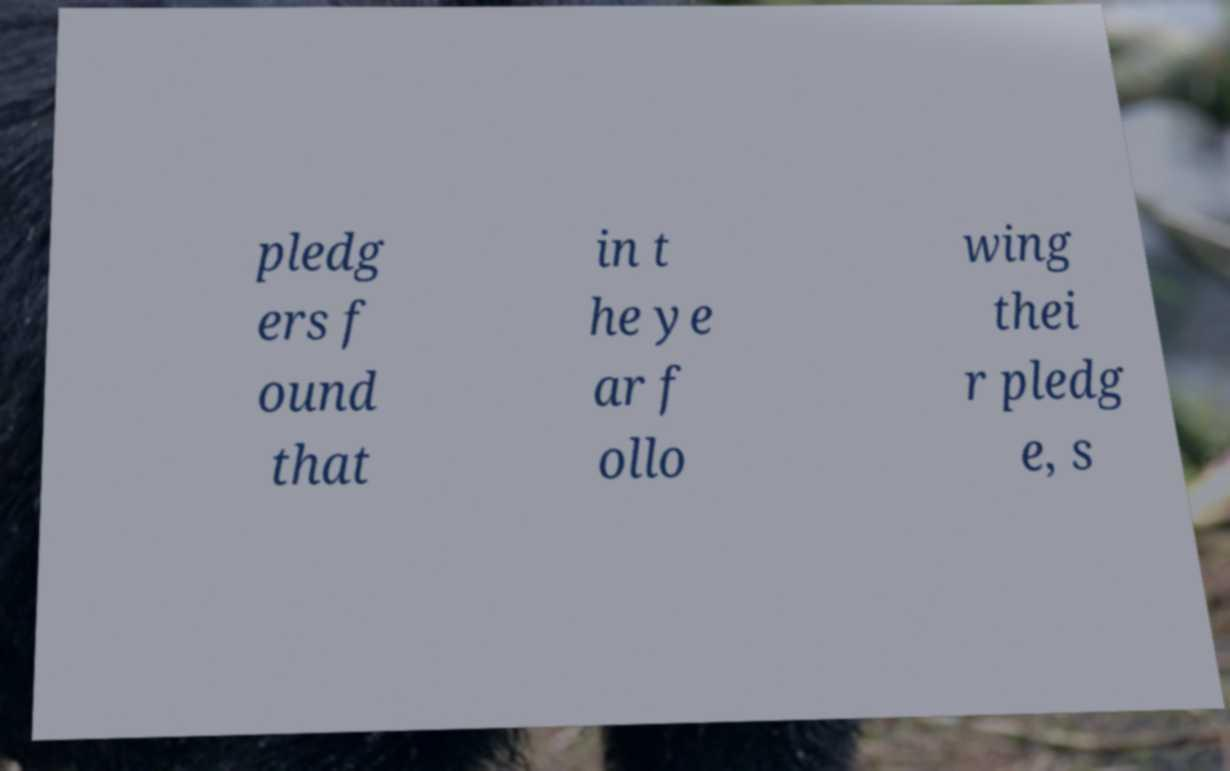There's text embedded in this image that I need extracted. Can you transcribe it verbatim? pledg ers f ound that in t he ye ar f ollo wing thei r pledg e, s 